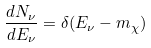<formula> <loc_0><loc_0><loc_500><loc_500>\frac { d N _ { \nu } } { d E _ { \nu } } = \delta ( E _ { \nu } - m _ { \chi } )</formula> 